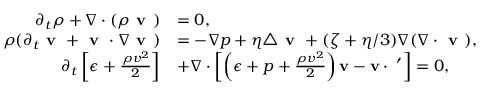Convert formula to latex. <formula><loc_0><loc_0><loc_500><loc_500>\begin{array} { r l } { \partial _ { t } \rho + \nabla \cdot ( \rho v ) } & { = 0 , } \\ { \rho ( \partial _ { t } v + v \cdot \nabla v ) } & { = - \nabla p + \eta \triangle v + ( \zeta + \eta / 3 ) \nabla ( \nabla \cdot v ) , } \\ { \partial _ { t } \left [ \epsilon + \frac { \rho v ^ { 2 } } { 2 } \right ] } & { + \nabla \cdot \left [ \left ( \epsilon + p + \frac { \rho v ^ { 2 } } { 2 } \right ) v - v \cdot \sigma ^ { \prime } \right ] = 0 , } \end{array}</formula> 